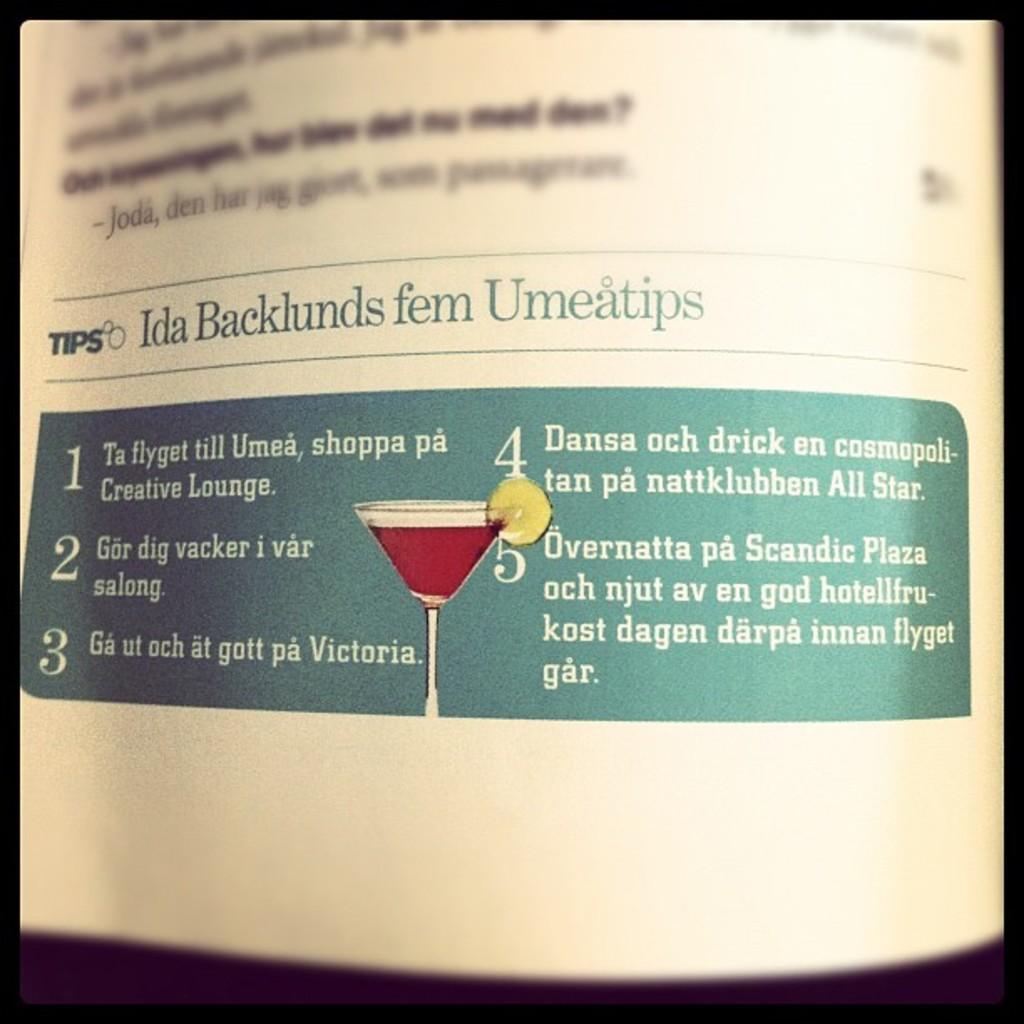What is the 2nd tip?
Give a very brief answer. Gor dig vacker i var salong. 